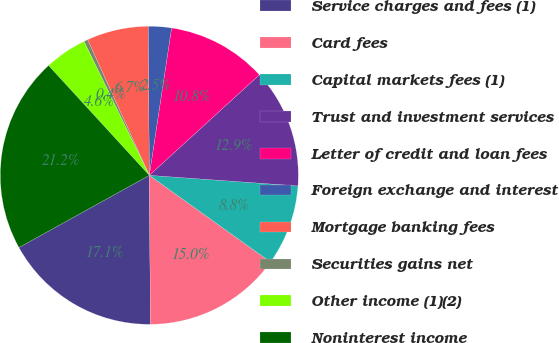Convert chart to OTSL. <chart><loc_0><loc_0><loc_500><loc_500><pie_chart><fcel>Service charges and fees (1)<fcel>Card fees<fcel>Capital markets fees (1)<fcel>Trust and investment services<fcel>Letter of credit and loan fees<fcel>Foreign exchange and interest<fcel>Mortgage banking fees<fcel>Securities gains net<fcel>Other income (1)(2)<fcel>Noninterest income<nl><fcel>17.07%<fcel>14.99%<fcel>8.75%<fcel>12.91%<fcel>10.83%<fcel>2.51%<fcel>6.67%<fcel>0.43%<fcel>4.59%<fcel>21.23%<nl></chart> 